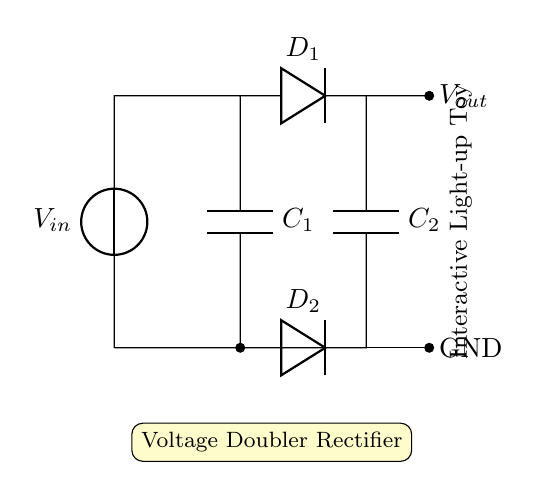What is the function of D1 in this circuit? D1 is a diode that allows current to flow in one direction, converting AC voltage into DC.
Answer: Diode What is the role of C1 in the voltage doubler rectifier? C1 is a capacitor that stores energy and helps smooth the voltage output, contributing to the voltage doubling effect.
Answer: Energy storage How many diodes are present in this circuit? There are two diodes, D1 and D2, used for rectifying the input voltage.
Answer: Two What does the output voltage represent in this circuit? The output voltage represents the double of the input voltage after rectification and filtering by the capacitors.
Answer: Voltage output What happens to the input voltage when it reaches D2? The input voltage is inverted and allows further charging of the second capacitor, C2, contributing to the voltage doubling.
Answer: It doubles What is the combined effect of C1 and C2? C1 and C2 work together to increase the output voltage by charging and discharging at different intervals during the rectification process.
Answer: Voltage doubling What is the total impact of this voltage doubler rectifier on an interactive light-up toy? The circuit increases the voltage to power the toy effectively, enabling brighter lights and better performance.
Answer: Enhanced performance 